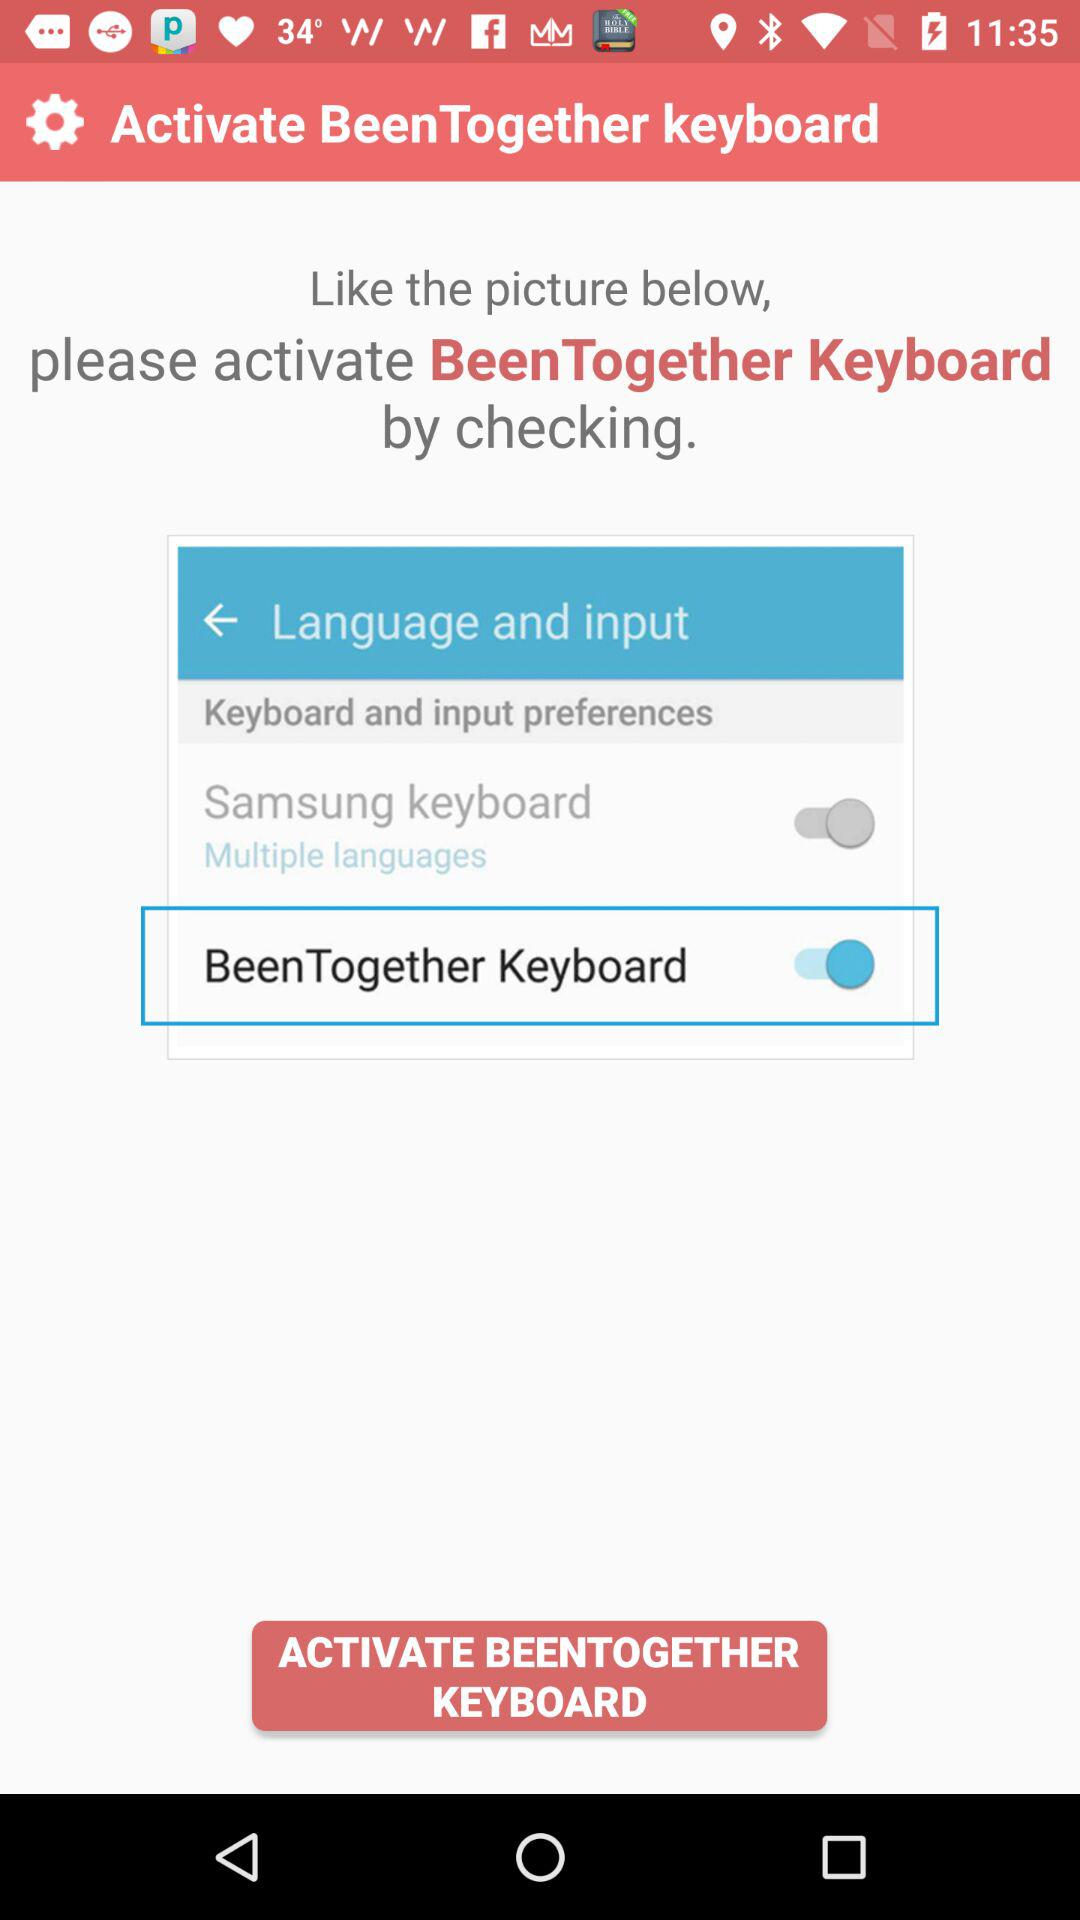What do we do to like the picture? To like the picture, you should activate the BeenTogether Keyboard by checking. 